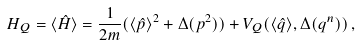Convert formula to latex. <formula><loc_0><loc_0><loc_500><loc_500>H _ { Q } = \langle \hat { H } \rangle = \frac { 1 } { 2 m } ( \langle \hat { p } \rangle ^ { 2 } + \Delta ( p ^ { 2 } ) ) + V _ { Q } ( \langle \hat { q } \rangle , \Delta ( q ^ { n } ) ) \, ,</formula> 